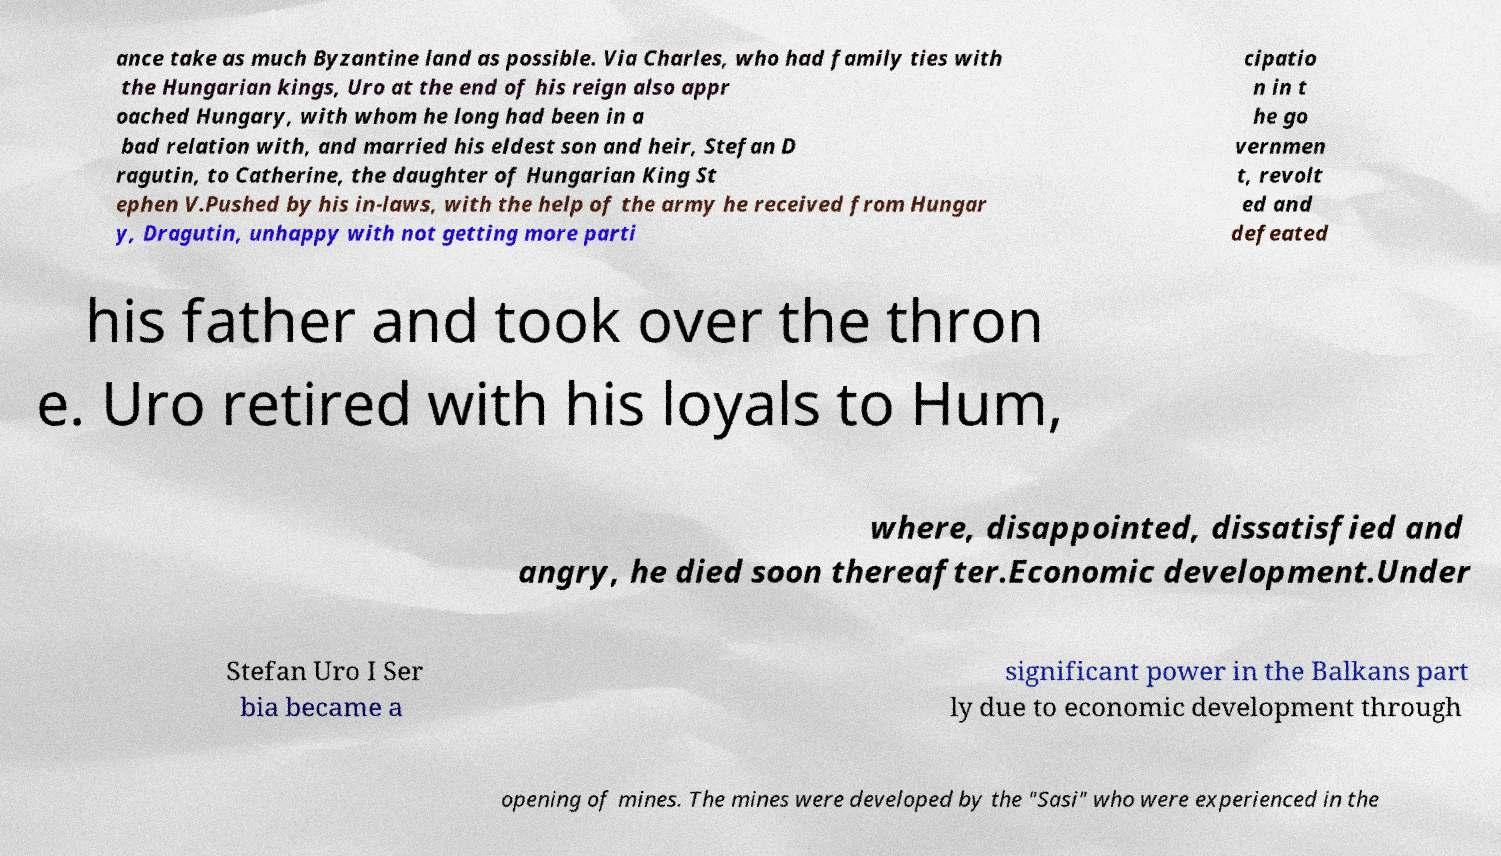Could you extract and type out the text from this image? ance take as much Byzantine land as possible. Via Charles, who had family ties with the Hungarian kings, Uro at the end of his reign also appr oached Hungary, with whom he long had been in a bad relation with, and married his eldest son and heir, Stefan D ragutin, to Catherine, the daughter of Hungarian King St ephen V.Pushed by his in-laws, with the help of the army he received from Hungar y, Dragutin, unhappy with not getting more parti cipatio n in t he go vernmen t, revolt ed and defeated his father and took over the thron e. Uro retired with his loyals to Hum, where, disappointed, dissatisfied and angry, he died soon thereafter.Economic development.Under Stefan Uro I Ser bia became a significant power in the Balkans part ly due to economic development through opening of mines. The mines were developed by the "Sasi" who were experienced in the 